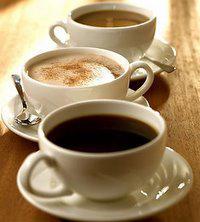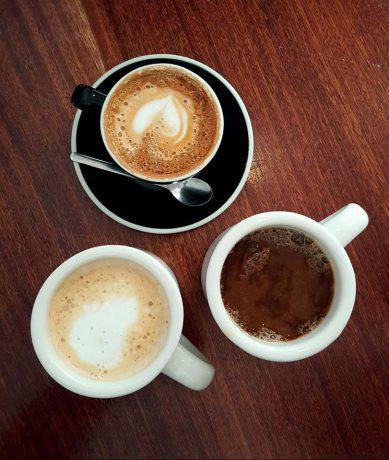The first image is the image on the left, the second image is the image on the right. Considering the images on both sides, is "Tea is being poured from a teapot into one of the white tea cups." valid? Answer yes or no. No. The first image is the image on the left, the second image is the image on the right. Considering the images on both sides, is "tea is being poured from a spout" valid? Answer yes or no. No. 